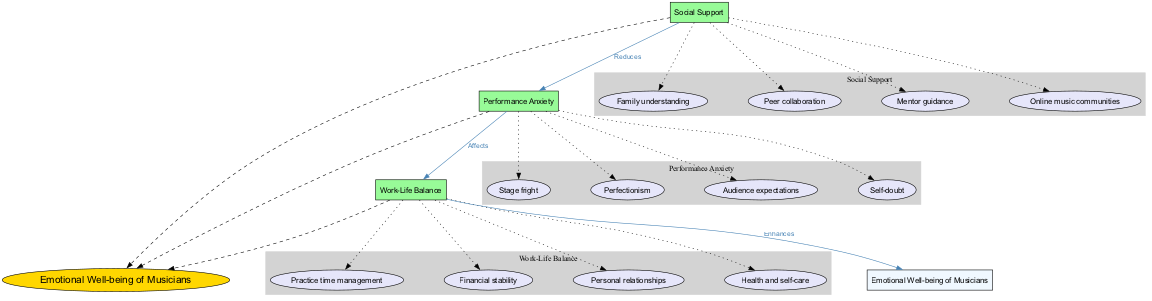What is the central concept of the diagram? The central concept, as indicated in the diagram, is the main theme around which other factors revolve. It is prominently highlighted as the 'Emotional Well-being of Musicians' at the center of the visual representation.
Answer: Emotional Well-being of Musicians How many main factors influence the emotional well-being of musicians? We can count the number of main factors listed in the diagram, which are clearly structured around the central concept. In this case, there are three main factors: Social Support, Performance Anxiety, and Work-Life Balance.
Answer: 3 What color represents the sub-factors in the diagram? The diagram distinctly shows each sub-factor within the categories, and all sub-factors are filled with the same color, which is a soft purple or lavender shade indicated by the fill color '#E6E6FA' in the code.
Answer: Light purple What relationship exists between Social Support and Performance Anxiety? The diagram indicates a specific connection conveying the nature of the relationship between these two factors. The label on this edge states that Social Support "Reduces" Performance Anxiety, showing a negative correlation in emotional well-being.
Answer: Reduces Which factor enhances emotional well-being according to the diagram? To find the factor that enhances emotional well-being, we can look at the connections leading toward the central concept. The connection indicates that Work-Life Balance "Enhances" the emotional well-being of musicians, thus proving it contributes positively.
Answer: Work-Life Balance What are the sub-factors under Performance Anxiety? By examining the cluster labeled as Performance Anxiety, we identify the separate elements contributing to this main factor. The sub-factors provided are Stage fright, Perfectionism, Audience expectations, and Self-doubt, clearly listed under this cluster.
Answer: Stage fright, Perfectionism, Audience expectations, Self-doubt How does Work-Life Balance affect emotional well-being? The edge labeled from Work-Life Balance to the central concept indicates a beneficial relationship. According to the diagram, it is articulated that Work-Life Balance "Enhances" emotional well-being, suggesting a positive impact on musicians.
Answer: Enhances What is the effect of Performance Anxiety on Work-Life Balance? By analyzing the directed edge from Performance Anxiety to Work-Life Balance, the relational label indicates that Performance Anxiety "Affects" Work-Life Balance. This suggests a potential negative influence of performance-related stress on balancing personal and professional life.
Answer: Affects Which sub-factor is part of Social Support? To find the sub-factors belonging to Social Support, we can look at the cluster associated with it. According to the diagram, the options listed include Family understanding, Peer collaboration, Mentor guidance, and Online music communities, showing the components of support.
Answer: Family understanding, Peer collaboration, Mentor guidance, Online music communities 